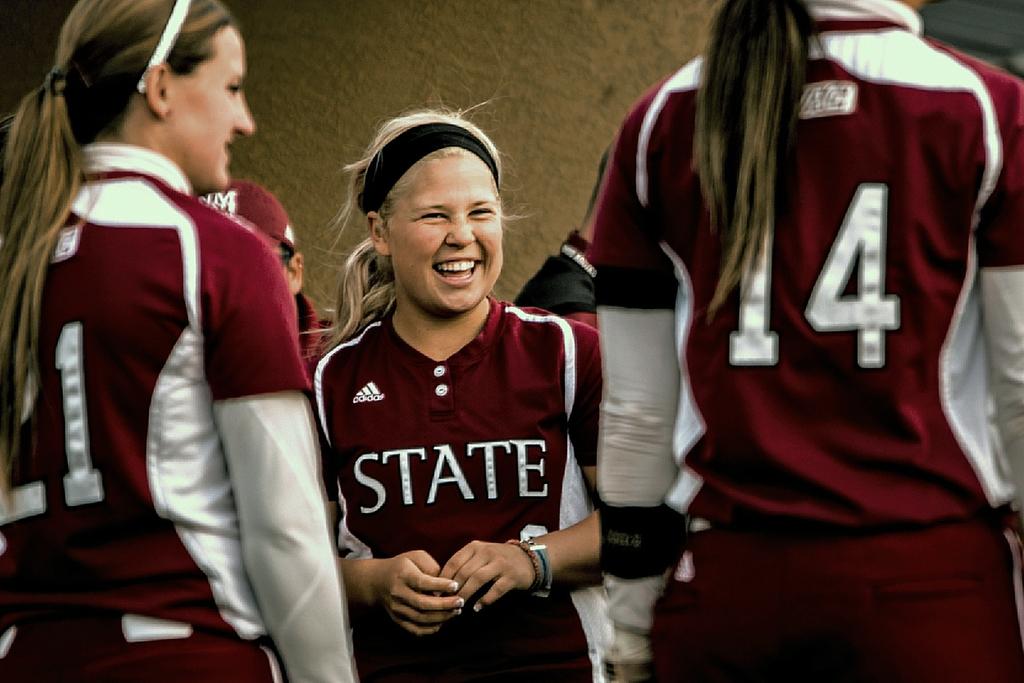What number is the player on the right?
Keep it short and to the point. 14. What is the word written on the uniform of the smiling girl?
Your response must be concise. State. 